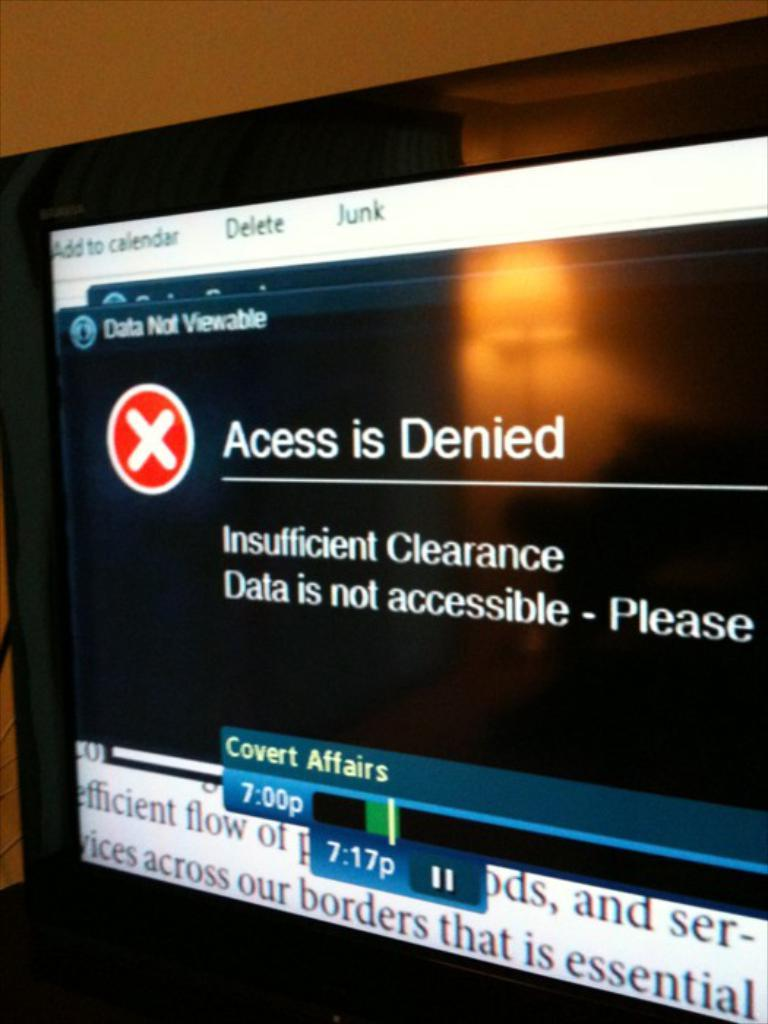Provide a one-sentence caption for the provided image. scrren showing a red and white x and access is denied message with the reason underneath. 